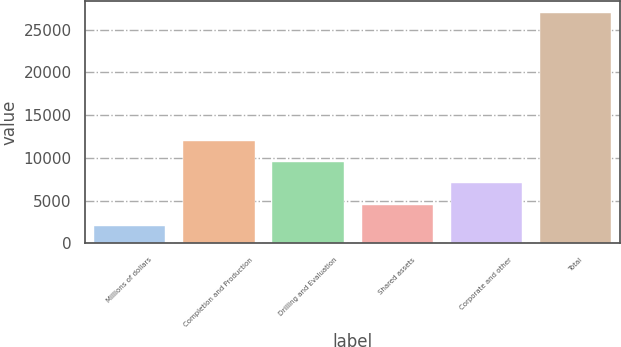<chart> <loc_0><loc_0><loc_500><loc_500><bar_chart><fcel>Millions of dollars<fcel>Completion and Production<fcel>Drilling and Evaluation<fcel>Shared assets<fcel>Corporate and other<fcel>Total<nl><fcel>2016<fcel>12009.6<fcel>9511.2<fcel>4514.4<fcel>7012.8<fcel>27000<nl></chart> 